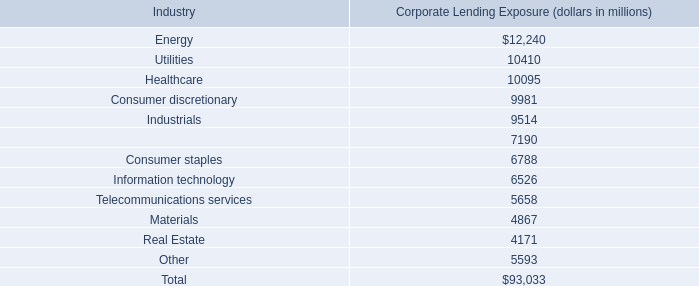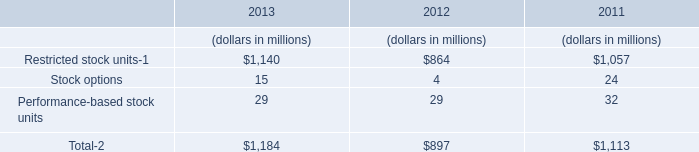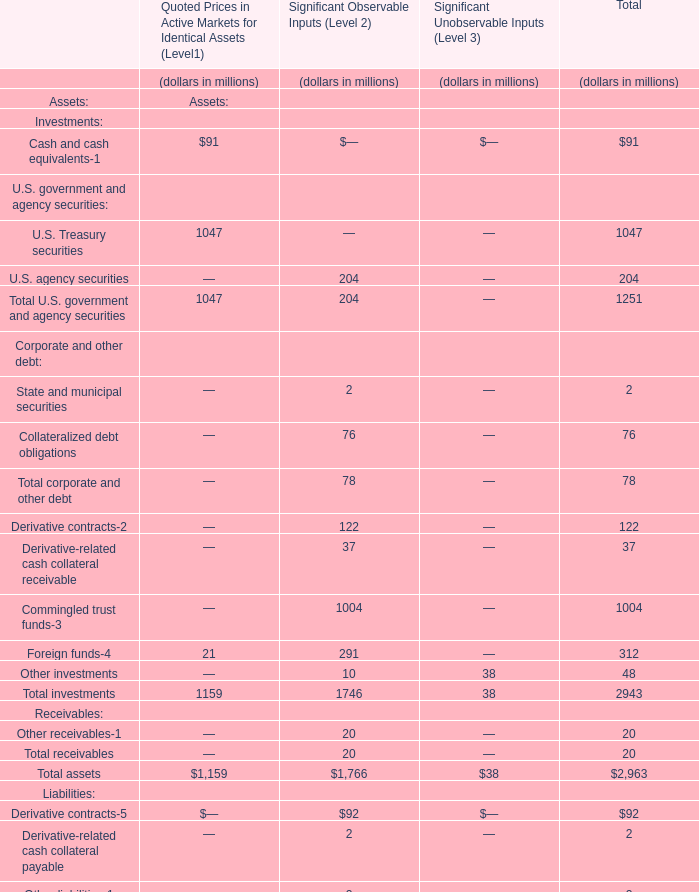Which section is Derivative-related cash collateral receivable the highest? 
Answer: Significant Observable Inputs (Level 2). 